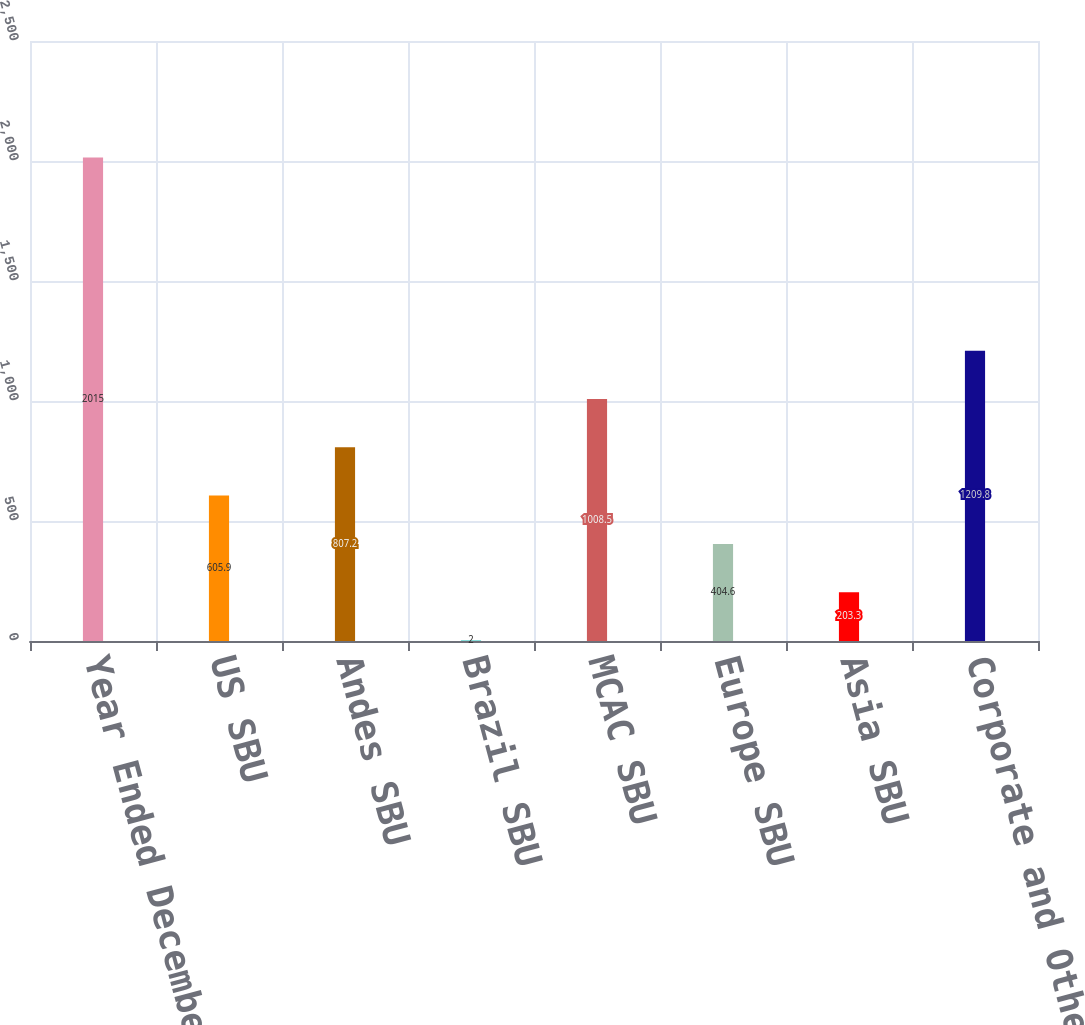Convert chart to OTSL. <chart><loc_0><loc_0><loc_500><loc_500><bar_chart><fcel>Year Ended December 31<fcel>US SBU<fcel>Andes SBU<fcel>Brazil SBU<fcel>MCAC SBU<fcel>Europe SBU<fcel>Asia SBU<fcel>Corporate and Other<nl><fcel>2015<fcel>605.9<fcel>807.2<fcel>2<fcel>1008.5<fcel>404.6<fcel>203.3<fcel>1209.8<nl></chart> 